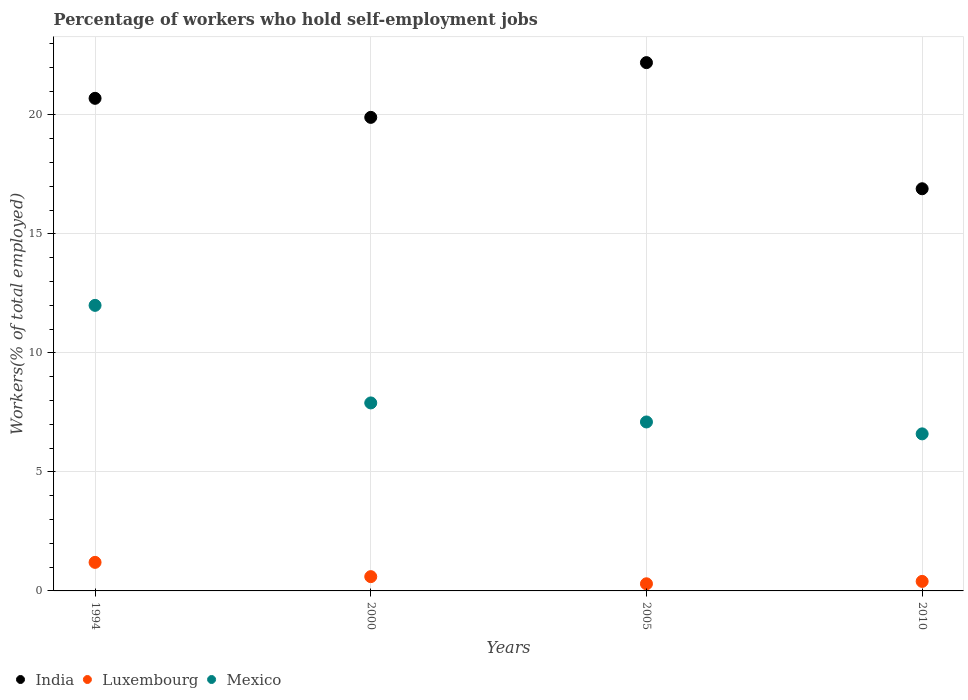How many different coloured dotlines are there?
Provide a succinct answer. 3. What is the percentage of self-employed workers in Luxembourg in 2005?
Keep it short and to the point. 0.3. Across all years, what is the maximum percentage of self-employed workers in India?
Ensure brevity in your answer.  22.2. Across all years, what is the minimum percentage of self-employed workers in India?
Provide a short and direct response. 16.9. In which year was the percentage of self-employed workers in Mexico minimum?
Ensure brevity in your answer.  2010. What is the total percentage of self-employed workers in India in the graph?
Keep it short and to the point. 79.7. What is the difference between the percentage of self-employed workers in Luxembourg in 2000 and that in 2010?
Provide a short and direct response. 0.2. What is the difference between the percentage of self-employed workers in Luxembourg in 2005 and the percentage of self-employed workers in Mexico in 2010?
Give a very brief answer. -6.3. What is the average percentage of self-employed workers in Luxembourg per year?
Keep it short and to the point. 0.63. In the year 1994, what is the difference between the percentage of self-employed workers in Mexico and percentage of self-employed workers in India?
Make the answer very short. -8.7. In how many years, is the percentage of self-employed workers in Mexico greater than 14 %?
Give a very brief answer. 0. What is the ratio of the percentage of self-employed workers in Mexico in 1994 to that in 2010?
Your answer should be compact. 1.82. What is the difference between the highest and the second highest percentage of self-employed workers in Mexico?
Keep it short and to the point. 4.1. What is the difference between the highest and the lowest percentage of self-employed workers in Luxembourg?
Your answer should be very brief. 0.9. In how many years, is the percentage of self-employed workers in India greater than the average percentage of self-employed workers in India taken over all years?
Make the answer very short. 2. Does the percentage of self-employed workers in Mexico monotonically increase over the years?
Your answer should be compact. No. How many dotlines are there?
Offer a terse response. 3. How many years are there in the graph?
Ensure brevity in your answer.  4. Are the values on the major ticks of Y-axis written in scientific E-notation?
Your answer should be very brief. No. Does the graph contain any zero values?
Make the answer very short. No. Does the graph contain grids?
Your answer should be very brief. Yes. What is the title of the graph?
Your answer should be very brief. Percentage of workers who hold self-employment jobs. What is the label or title of the X-axis?
Your answer should be compact. Years. What is the label or title of the Y-axis?
Make the answer very short. Workers(% of total employed). What is the Workers(% of total employed) of India in 1994?
Make the answer very short. 20.7. What is the Workers(% of total employed) in Luxembourg in 1994?
Your answer should be very brief. 1.2. What is the Workers(% of total employed) of Mexico in 1994?
Offer a terse response. 12. What is the Workers(% of total employed) of India in 2000?
Keep it short and to the point. 19.9. What is the Workers(% of total employed) in Luxembourg in 2000?
Your response must be concise. 0.6. What is the Workers(% of total employed) of Mexico in 2000?
Your answer should be compact. 7.9. What is the Workers(% of total employed) of India in 2005?
Provide a short and direct response. 22.2. What is the Workers(% of total employed) in Luxembourg in 2005?
Ensure brevity in your answer.  0.3. What is the Workers(% of total employed) in Mexico in 2005?
Offer a very short reply. 7.1. What is the Workers(% of total employed) in India in 2010?
Provide a short and direct response. 16.9. What is the Workers(% of total employed) in Luxembourg in 2010?
Offer a very short reply. 0.4. What is the Workers(% of total employed) in Mexico in 2010?
Provide a short and direct response. 6.6. Across all years, what is the maximum Workers(% of total employed) of India?
Your answer should be very brief. 22.2. Across all years, what is the maximum Workers(% of total employed) of Luxembourg?
Offer a very short reply. 1.2. Across all years, what is the minimum Workers(% of total employed) of India?
Your answer should be very brief. 16.9. Across all years, what is the minimum Workers(% of total employed) of Luxembourg?
Your answer should be compact. 0.3. Across all years, what is the minimum Workers(% of total employed) of Mexico?
Your answer should be compact. 6.6. What is the total Workers(% of total employed) in India in the graph?
Provide a short and direct response. 79.7. What is the total Workers(% of total employed) of Mexico in the graph?
Make the answer very short. 33.6. What is the difference between the Workers(% of total employed) of Mexico in 2000 and that in 2005?
Your answer should be compact. 0.8. What is the difference between the Workers(% of total employed) of India in 2005 and that in 2010?
Your answer should be compact. 5.3. What is the difference between the Workers(% of total employed) in Mexico in 2005 and that in 2010?
Give a very brief answer. 0.5. What is the difference between the Workers(% of total employed) of India in 1994 and the Workers(% of total employed) of Luxembourg in 2000?
Keep it short and to the point. 20.1. What is the difference between the Workers(% of total employed) of India in 1994 and the Workers(% of total employed) of Mexico in 2000?
Your answer should be very brief. 12.8. What is the difference between the Workers(% of total employed) of Luxembourg in 1994 and the Workers(% of total employed) of Mexico in 2000?
Ensure brevity in your answer.  -6.7. What is the difference between the Workers(% of total employed) in India in 1994 and the Workers(% of total employed) in Luxembourg in 2005?
Your answer should be very brief. 20.4. What is the difference between the Workers(% of total employed) in India in 1994 and the Workers(% of total employed) in Mexico in 2005?
Keep it short and to the point. 13.6. What is the difference between the Workers(% of total employed) in Luxembourg in 1994 and the Workers(% of total employed) in Mexico in 2005?
Give a very brief answer. -5.9. What is the difference between the Workers(% of total employed) in India in 1994 and the Workers(% of total employed) in Luxembourg in 2010?
Your answer should be compact. 20.3. What is the difference between the Workers(% of total employed) of Luxembourg in 1994 and the Workers(% of total employed) of Mexico in 2010?
Your answer should be very brief. -5.4. What is the difference between the Workers(% of total employed) in India in 2000 and the Workers(% of total employed) in Luxembourg in 2005?
Your answer should be very brief. 19.6. What is the difference between the Workers(% of total employed) in India in 2000 and the Workers(% of total employed) in Mexico in 2005?
Give a very brief answer. 12.8. What is the difference between the Workers(% of total employed) in India in 2000 and the Workers(% of total employed) in Mexico in 2010?
Your answer should be very brief. 13.3. What is the difference between the Workers(% of total employed) of Luxembourg in 2000 and the Workers(% of total employed) of Mexico in 2010?
Your answer should be compact. -6. What is the difference between the Workers(% of total employed) of India in 2005 and the Workers(% of total employed) of Luxembourg in 2010?
Provide a succinct answer. 21.8. What is the difference between the Workers(% of total employed) in Luxembourg in 2005 and the Workers(% of total employed) in Mexico in 2010?
Ensure brevity in your answer.  -6.3. What is the average Workers(% of total employed) in India per year?
Offer a very short reply. 19.93. What is the average Workers(% of total employed) in Luxembourg per year?
Your answer should be very brief. 0.62. What is the average Workers(% of total employed) of Mexico per year?
Make the answer very short. 8.4. In the year 1994, what is the difference between the Workers(% of total employed) in India and Workers(% of total employed) in Luxembourg?
Your answer should be compact. 19.5. In the year 1994, what is the difference between the Workers(% of total employed) in Luxembourg and Workers(% of total employed) in Mexico?
Offer a terse response. -10.8. In the year 2000, what is the difference between the Workers(% of total employed) in India and Workers(% of total employed) in Luxembourg?
Keep it short and to the point. 19.3. In the year 2000, what is the difference between the Workers(% of total employed) of Luxembourg and Workers(% of total employed) of Mexico?
Make the answer very short. -7.3. In the year 2005, what is the difference between the Workers(% of total employed) of India and Workers(% of total employed) of Luxembourg?
Ensure brevity in your answer.  21.9. In the year 2005, what is the difference between the Workers(% of total employed) of Luxembourg and Workers(% of total employed) of Mexico?
Make the answer very short. -6.8. In the year 2010, what is the difference between the Workers(% of total employed) in India and Workers(% of total employed) in Luxembourg?
Ensure brevity in your answer.  16.5. In the year 2010, what is the difference between the Workers(% of total employed) of Luxembourg and Workers(% of total employed) of Mexico?
Your answer should be compact. -6.2. What is the ratio of the Workers(% of total employed) in India in 1994 to that in 2000?
Your answer should be very brief. 1.04. What is the ratio of the Workers(% of total employed) in Luxembourg in 1994 to that in 2000?
Your answer should be compact. 2. What is the ratio of the Workers(% of total employed) in Mexico in 1994 to that in 2000?
Offer a terse response. 1.52. What is the ratio of the Workers(% of total employed) in India in 1994 to that in 2005?
Provide a succinct answer. 0.93. What is the ratio of the Workers(% of total employed) in Mexico in 1994 to that in 2005?
Your response must be concise. 1.69. What is the ratio of the Workers(% of total employed) in India in 1994 to that in 2010?
Offer a terse response. 1.22. What is the ratio of the Workers(% of total employed) in Mexico in 1994 to that in 2010?
Ensure brevity in your answer.  1.82. What is the ratio of the Workers(% of total employed) in India in 2000 to that in 2005?
Your answer should be very brief. 0.9. What is the ratio of the Workers(% of total employed) in Mexico in 2000 to that in 2005?
Your response must be concise. 1.11. What is the ratio of the Workers(% of total employed) in India in 2000 to that in 2010?
Your answer should be very brief. 1.18. What is the ratio of the Workers(% of total employed) of Luxembourg in 2000 to that in 2010?
Keep it short and to the point. 1.5. What is the ratio of the Workers(% of total employed) of Mexico in 2000 to that in 2010?
Your answer should be compact. 1.2. What is the ratio of the Workers(% of total employed) of India in 2005 to that in 2010?
Keep it short and to the point. 1.31. What is the ratio of the Workers(% of total employed) in Luxembourg in 2005 to that in 2010?
Give a very brief answer. 0.75. What is the ratio of the Workers(% of total employed) in Mexico in 2005 to that in 2010?
Your answer should be compact. 1.08. What is the difference between the highest and the second highest Workers(% of total employed) in India?
Give a very brief answer. 1.5. What is the difference between the highest and the lowest Workers(% of total employed) of Mexico?
Make the answer very short. 5.4. 